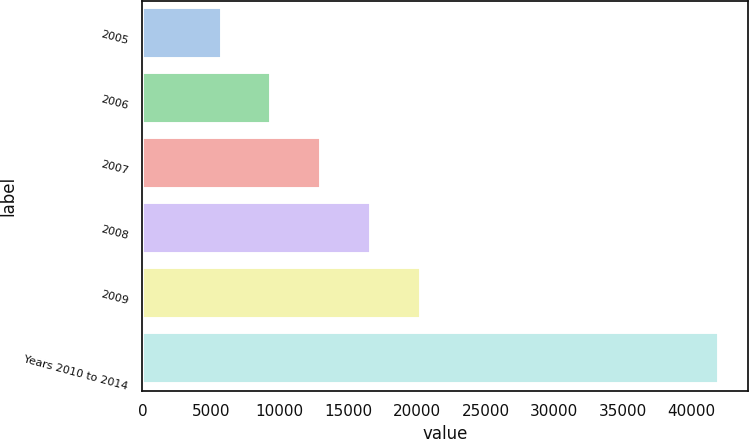<chart> <loc_0><loc_0><loc_500><loc_500><bar_chart><fcel>2005<fcel>2006<fcel>2007<fcel>2008<fcel>2009<fcel>Years 2010 to 2014<nl><fcel>5779<fcel>9403.8<fcel>13028.6<fcel>16653.4<fcel>20278.2<fcel>42027<nl></chart> 